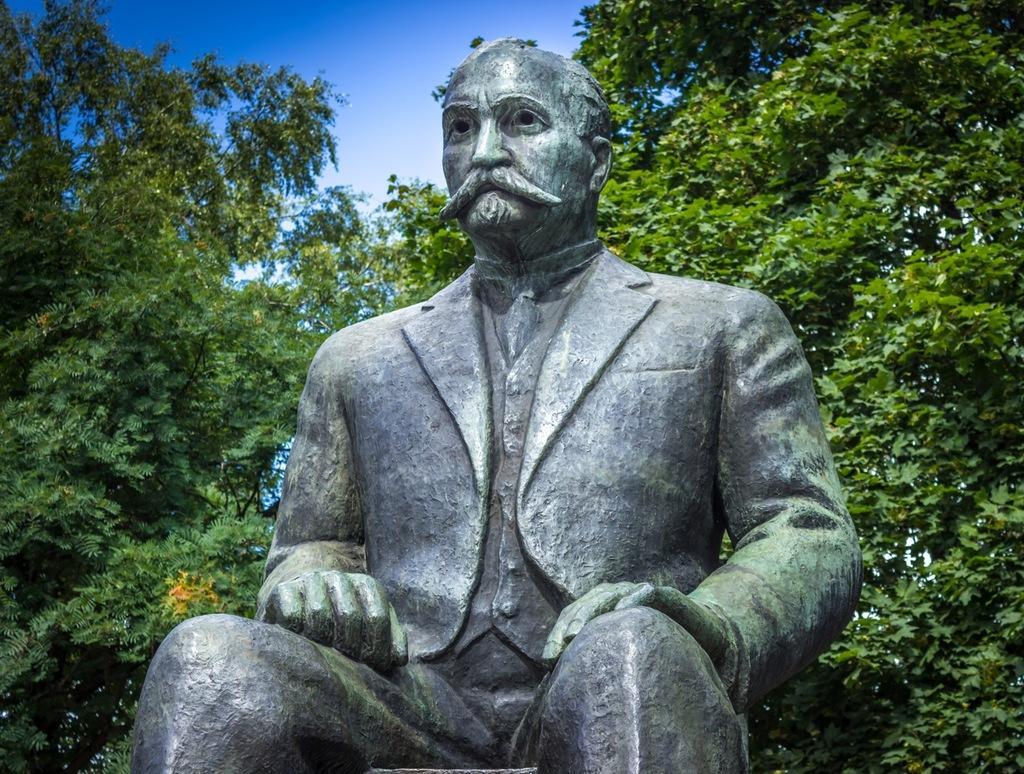In one or two sentences, can you explain what this image depicts? In this image there is a statue of a man who is sitting. In the background there are trees. At the top there is the sky. 